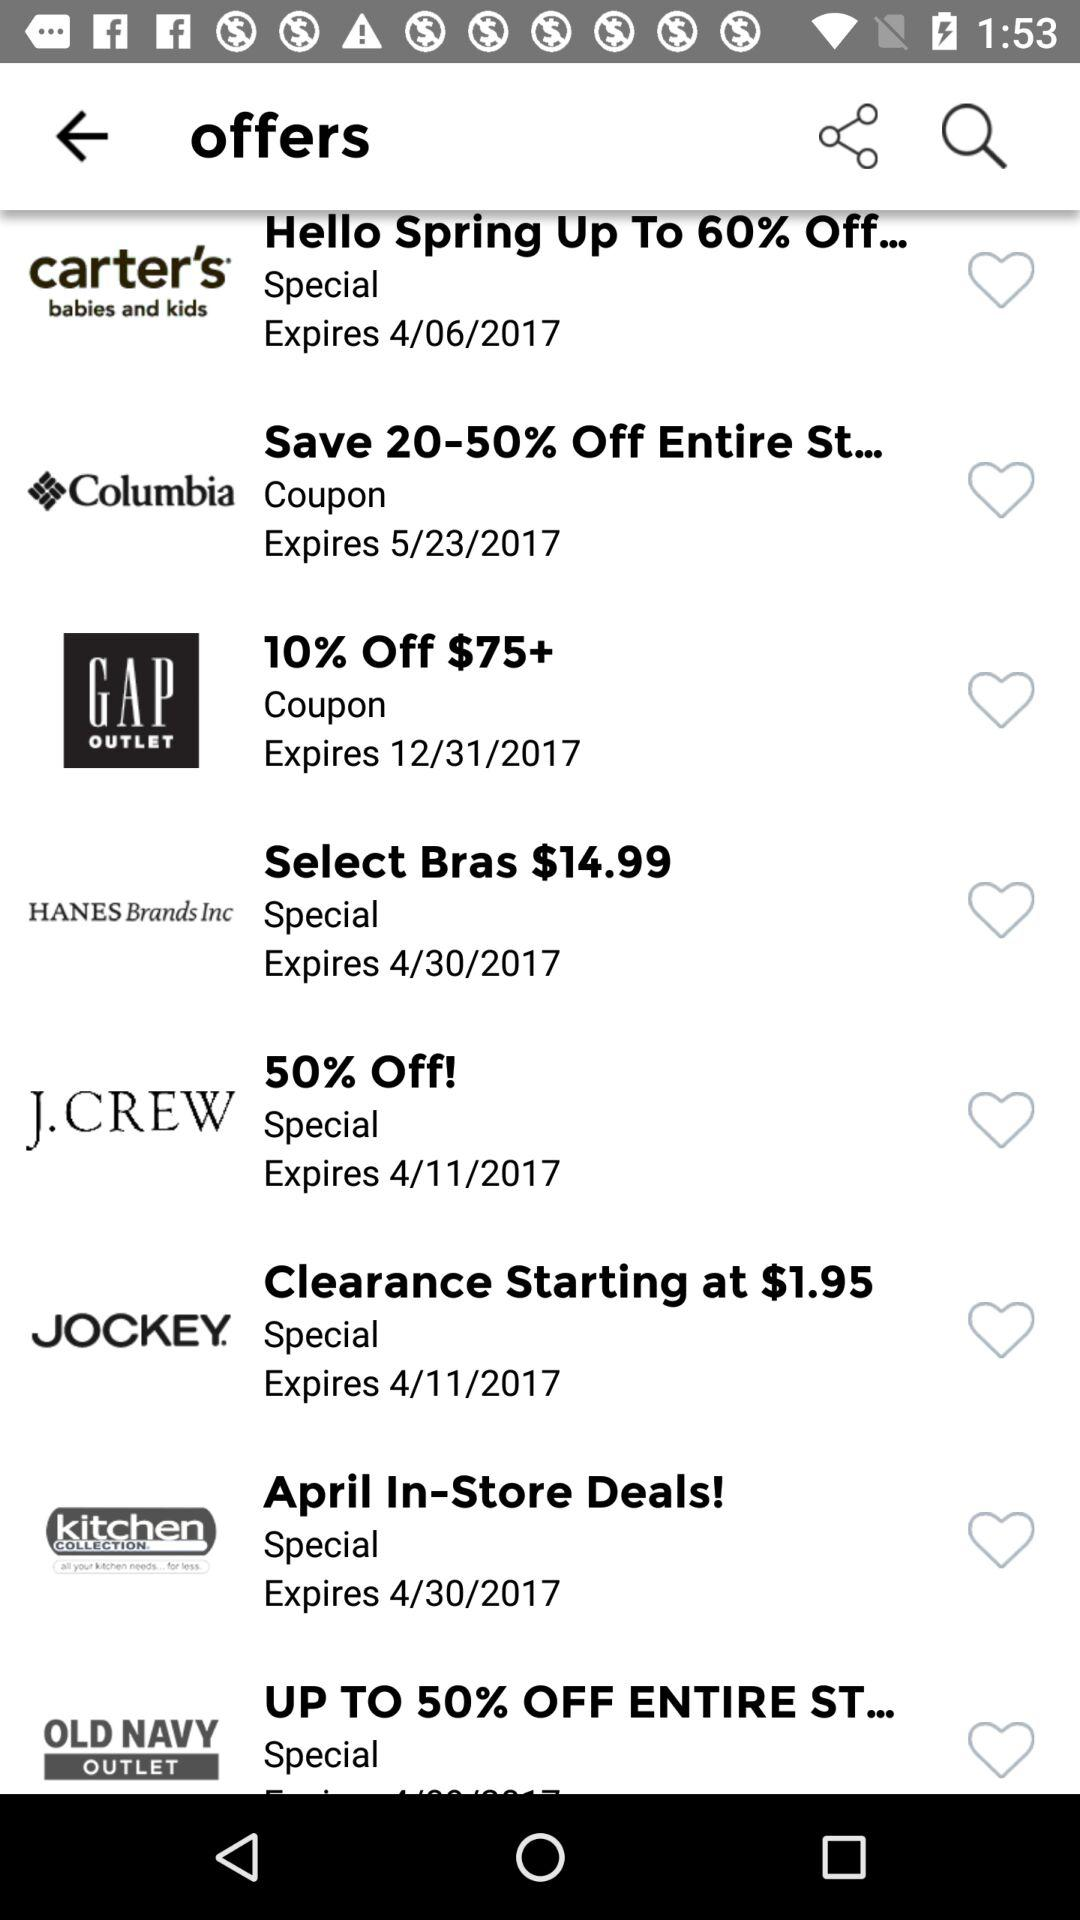What is the expiry date of the jockey coupon? The expiry date is 4/11/2017. 